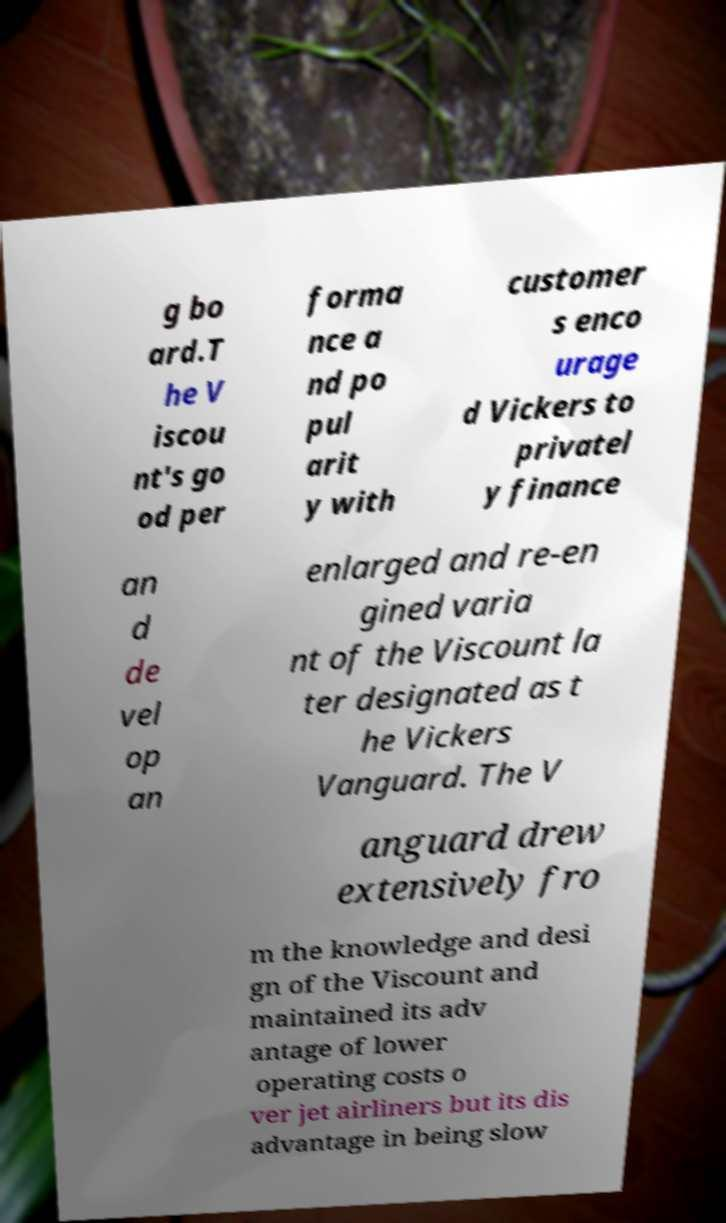What messages or text are displayed in this image? I need them in a readable, typed format. g bo ard.T he V iscou nt's go od per forma nce a nd po pul arit y with customer s enco urage d Vickers to privatel y finance an d de vel op an enlarged and re-en gined varia nt of the Viscount la ter designated as t he Vickers Vanguard. The V anguard drew extensively fro m the knowledge and desi gn of the Viscount and maintained its adv antage of lower operating costs o ver jet airliners but its dis advantage in being slow 